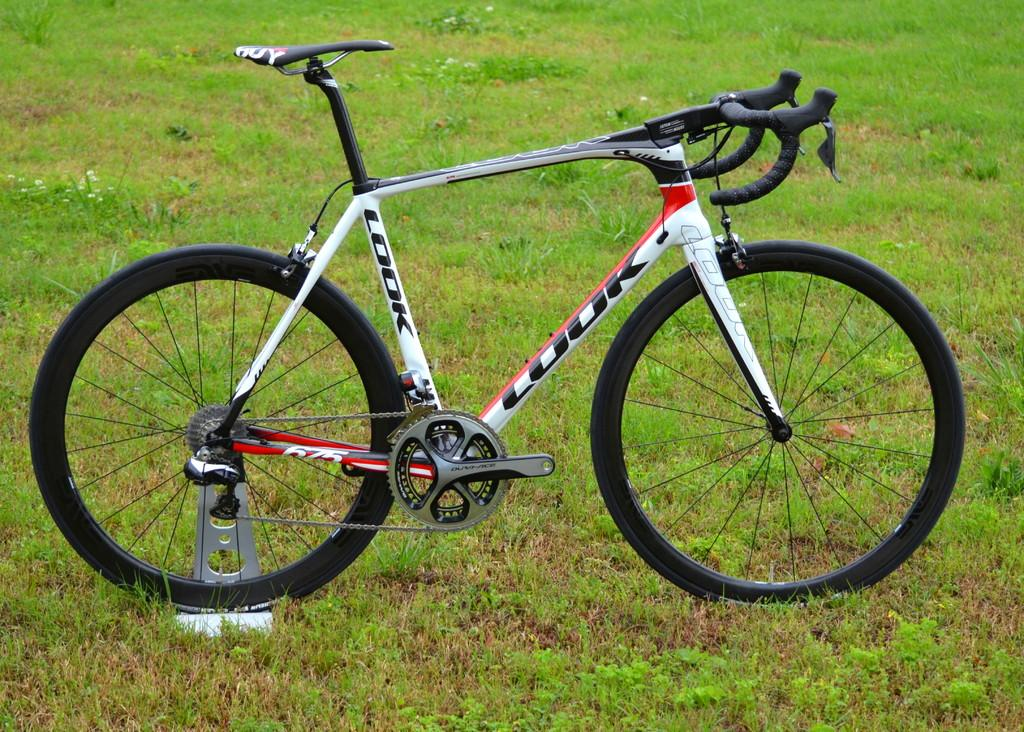What is the main object in the picture? There is a bicycle in the picture. What is the color of the bicycle? The bicycle is white in color. What are the colors of the wheels, handle, and seat? The wheels, handle, and seat are black. On what surface is the bicycle placed? The bicycle is placed on a grass surface. How does the bicycle express its feelings of hate in the image? The bicycle does not express any feelings in the image, as it is an inanimate object. 